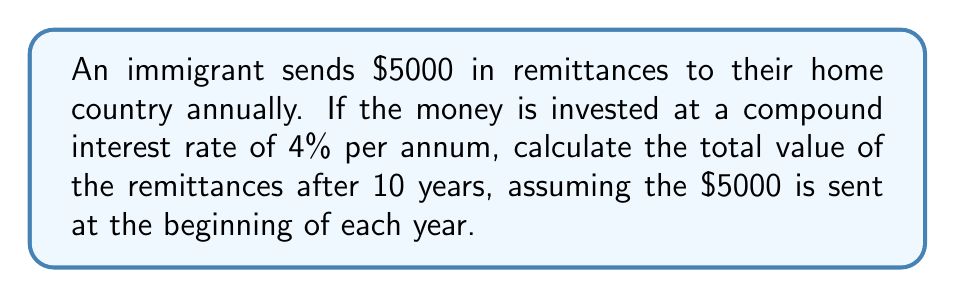Provide a solution to this math problem. To solve this problem, we'll use the compound interest formula for regular payments:

$$A = P \cdot \frac{(1 + r)^n - 1}{r}$$

Where:
$A$ = Final amount
$P$ = Regular payment (annual remittance)
$r$ = Annual interest rate (as a decimal)
$n$ = Number of years

Step 1: Identify the values
$P = 5000$
$r = 0.04$ (4% converted to decimal)
$n = 10$ years

Step 2: Substitute these values into the formula
$$A = 5000 \cdot \frac{(1 + 0.04)^{10} - 1}{0.04}$$

Step 3: Calculate $(1 + 0.04)^{10}$
$(1.04)^{10} = 1.4802$

Step 4: Subtract 1 from the result in step 3
$1.4802 - 1 = 0.4802$

Step 5: Divide the result from step 4 by 0.04
$0.4802 \div 0.04 = 12.0050$

Step 6: Multiply the result from step 5 by 5000
$5000 \times 12.0050 = 60,025$

Therefore, the total value of the remittances after 10 years is $60,025.
Answer: $60,025 